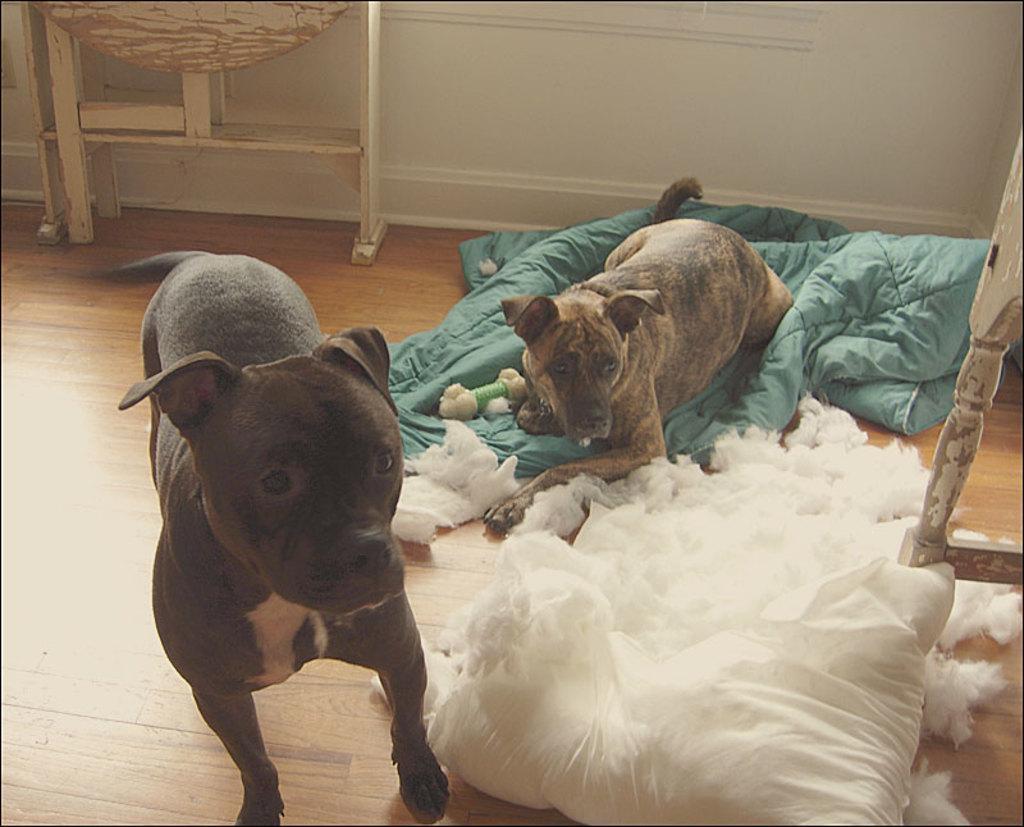In one or two sentences, can you explain what this image depicts? In this image we can see two dogs, among them one dog is on the clothes, also we can see some cotton and other objects, in the background, we can see the wall. 